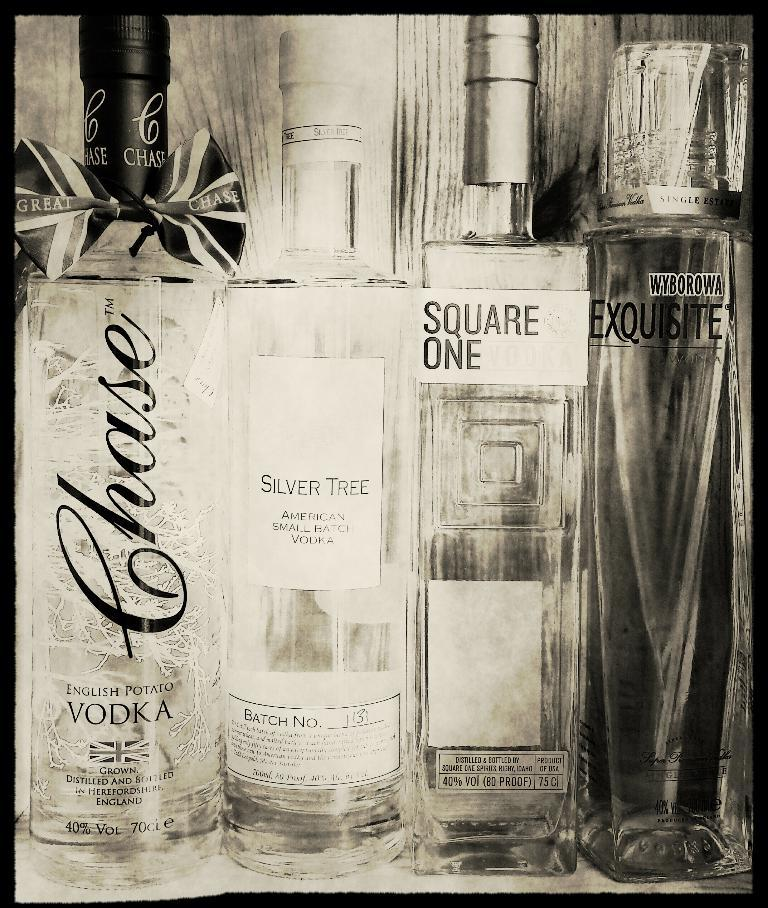<image>
Provide a brief description of the given image. Different bottles of vodka are displayed in front of a wood wall. 